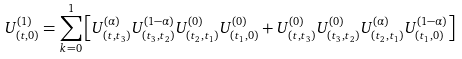<formula> <loc_0><loc_0><loc_500><loc_500>U ^ { ( 1 ) } _ { ( t , 0 ) } = \sum _ { k = 0 } ^ { 1 } \left [ U ^ { ( \alpha ) } _ { ( t , t _ { 3 } ) } U ^ { ( 1 - \alpha ) } _ { ( t _ { 3 } , t _ { 2 } ) } U ^ { ( 0 ) } _ { ( t _ { 2 } , t _ { 1 } ) } U ^ { ( 0 ) } _ { ( t _ { 1 } , 0 ) } + U ^ { ( 0 ) } _ { ( t , t _ { 3 } ) } U ^ { ( 0 ) } _ { ( t _ { 3 } , t _ { 2 } ) } U ^ { ( \alpha ) } _ { ( t _ { 2 } , t _ { 1 } ) } U ^ { ( 1 - \alpha ) } _ { ( t _ { 1 } , 0 ) } \right ]</formula> 